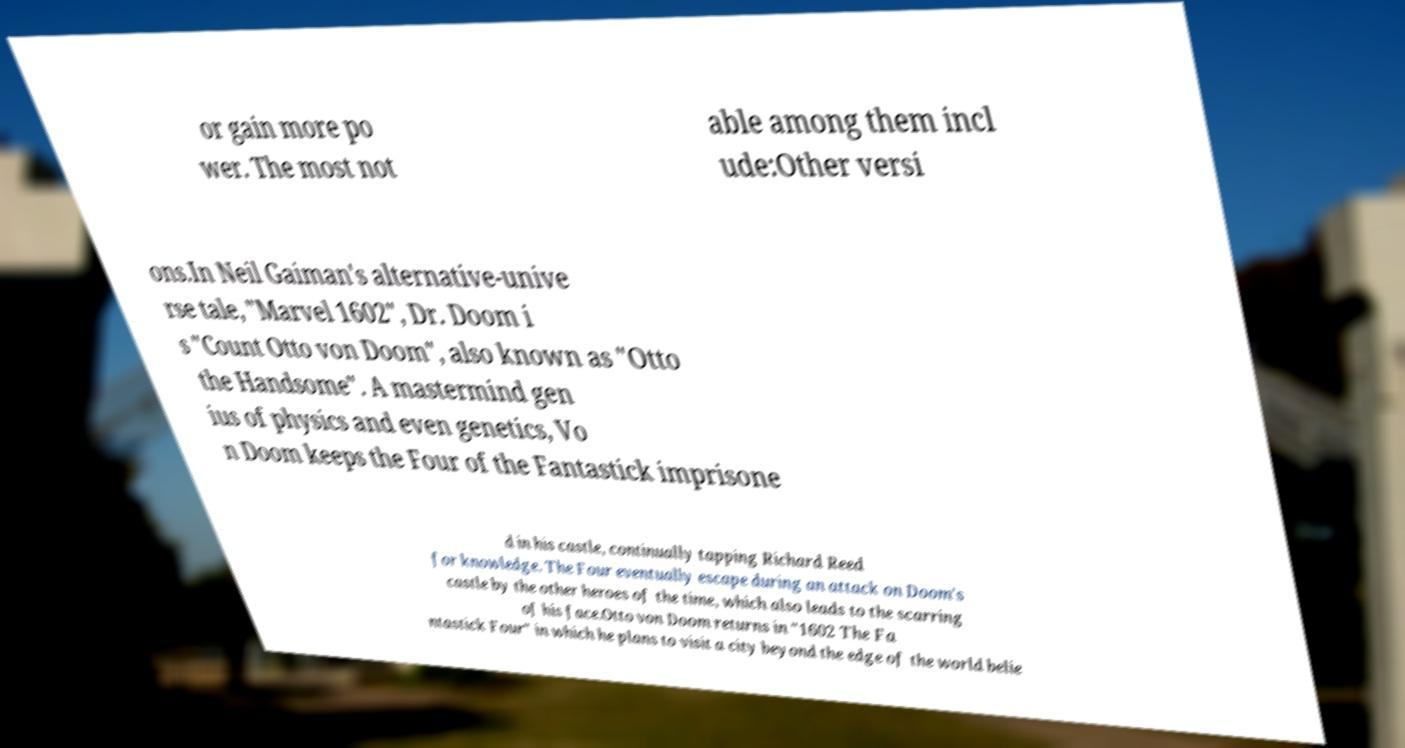What messages or text are displayed in this image? I need them in a readable, typed format. or gain more po wer. The most not able among them incl ude:Other versi ons.In Neil Gaiman's alternative-unive rse tale, "Marvel 1602", Dr. Doom i s "Count Otto von Doom", also known as "Otto the Handsome". A mastermind gen ius of physics and even genetics, Vo n Doom keeps the Four of the Fantastick imprisone d in his castle, continually tapping Richard Reed for knowledge. The Four eventually escape during an attack on Doom's castle by the other heroes of the time, which also leads to the scarring of his face.Otto von Doom returns in "1602 The Fa ntastick Four" in which he plans to visit a city beyond the edge of the world belie 